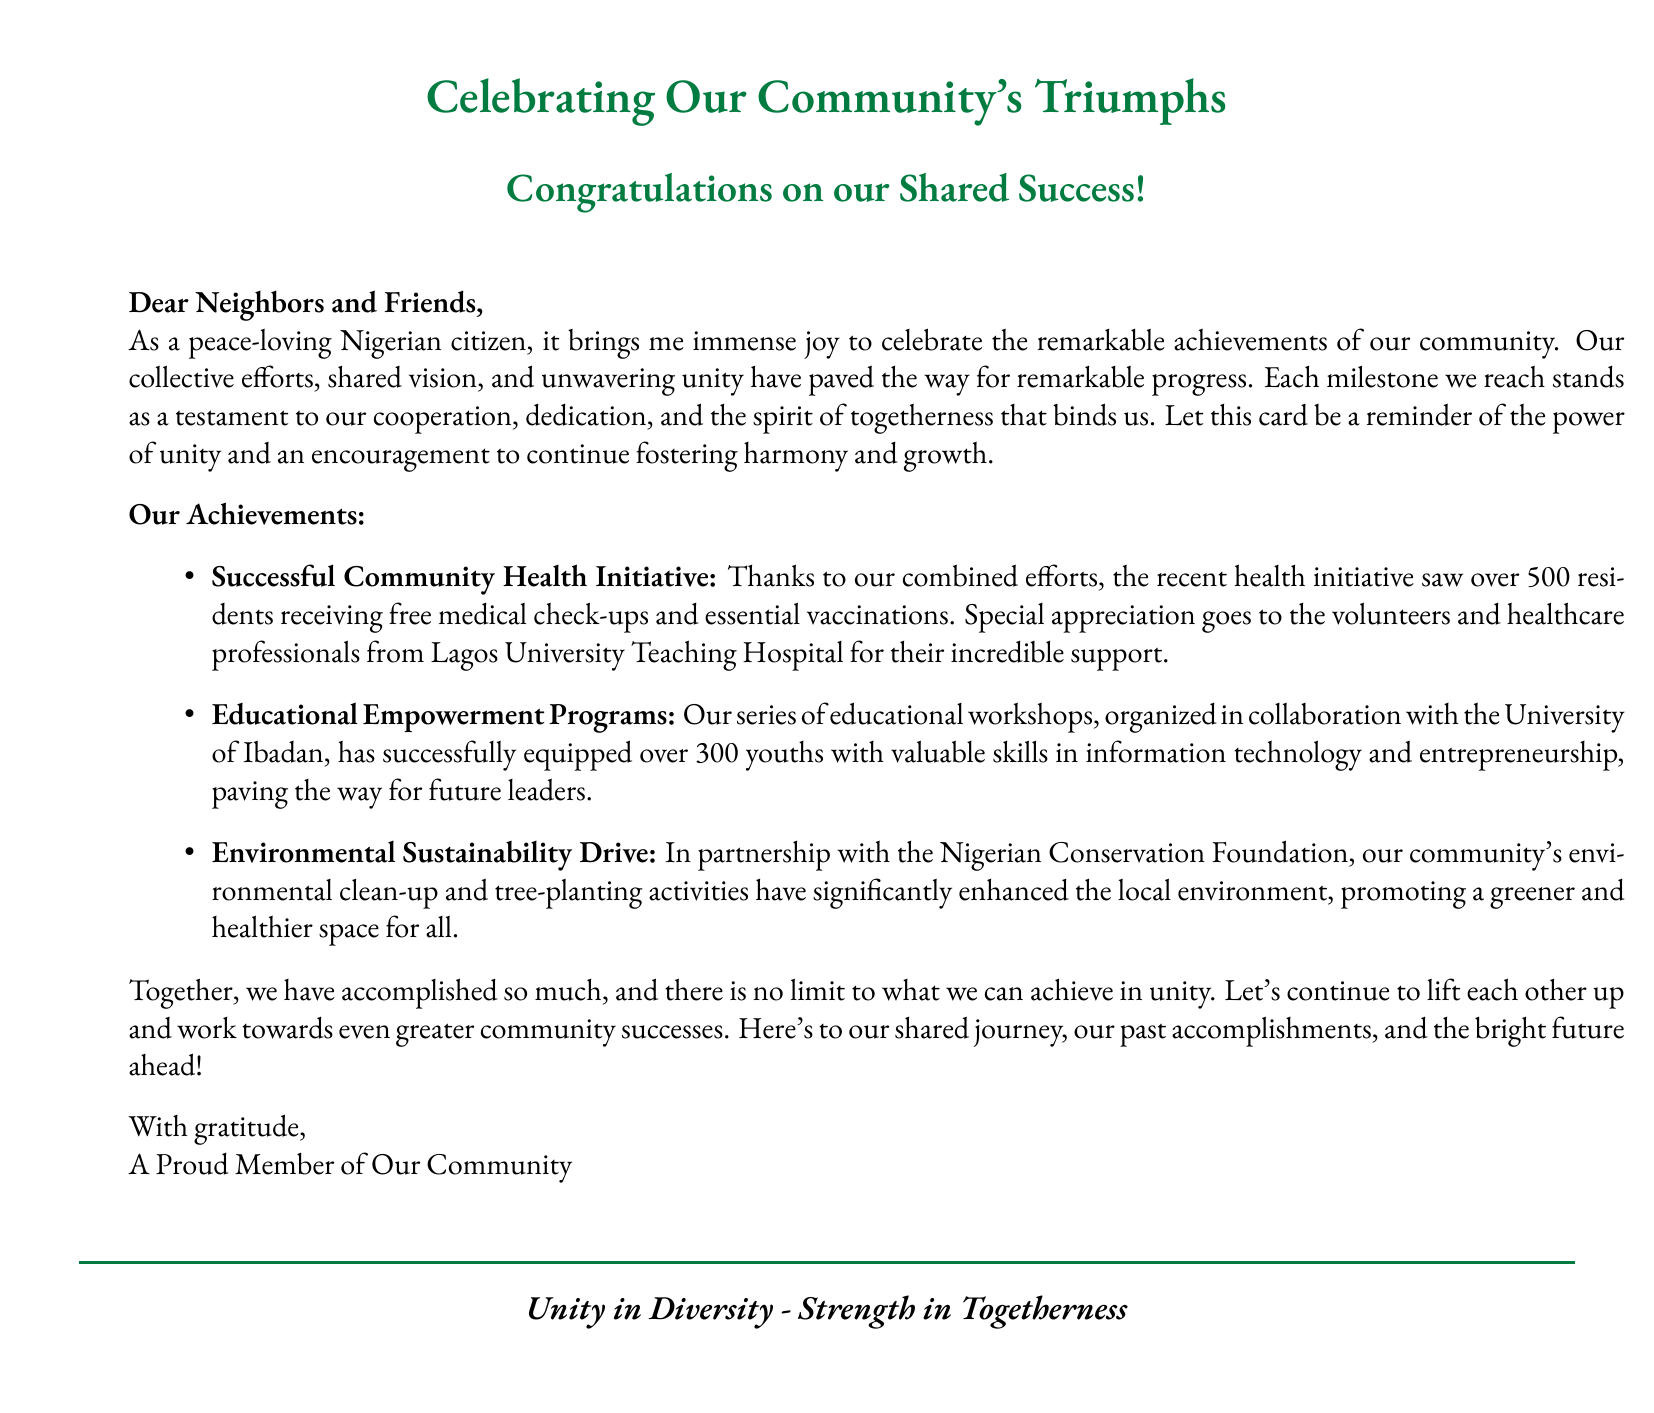What is the title of the card? The title is the main heading presented in the document, which highlights the celebration of community achievements.
Answer: Celebrating Our Community's Triumphs Who is the card addressed to? The salutation indicates the recipients of the card, which includes community members.
Answer: Neighbors and Friends How many residents received medical check-ups? This number reflects the achievement of the health initiative mentioned in the document.
Answer: 500 What organization supported the health initiative? This refers to the institution that contributed to the community health event.
Answer: Lagos University Teaching Hospital What skills were offered in the educational empowerment programs? This pertains to the focus area of the workshops detailed in the document.
Answer: Information technology and entrepreneurship What was the focus of the environmental initiative? This describes the primary focus of the drive mentioned in the document.
Answer: Clean-up and tree-planting activities What does the closing statement emphasize? This phrase highlights the document's overarching theme regarding community strengths.
Answer: Unity in Diversity - Strength in Togetherness 